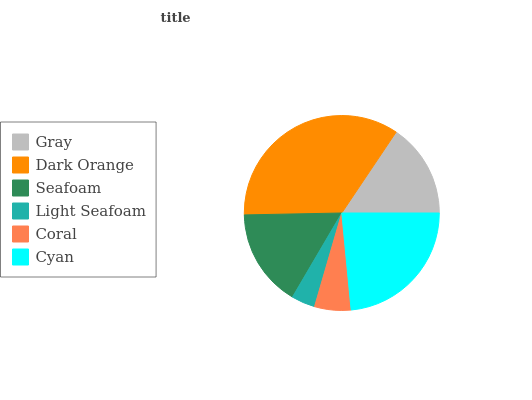Is Light Seafoam the minimum?
Answer yes or no. Yes. Is Dark Orange the maximum?
Answer yes or no. Yes. Is Seafoam the minimum?
Answer yes or no. No. Is Seafoam the maximum?
Answer yes or no. No. Is Dark Orange greater than Seafoam?
Answer yes or no. Yes. Is Seafoam less than Dark Orange?
Answer yes or no. Yes. Is Seafoam greater than Dark Orange?
Answer yes or no. No. Is Dark Orange less than Seafoam?
Answer yes or no. No. Is Seafoam the high median?
Answer yes or no. Yes. Is Gray the low median?
Answer yes or no. Yes. Is Coral the high median?
Answer yes or no. No. Is Cyan the low median?
Answer yes or no. No. 